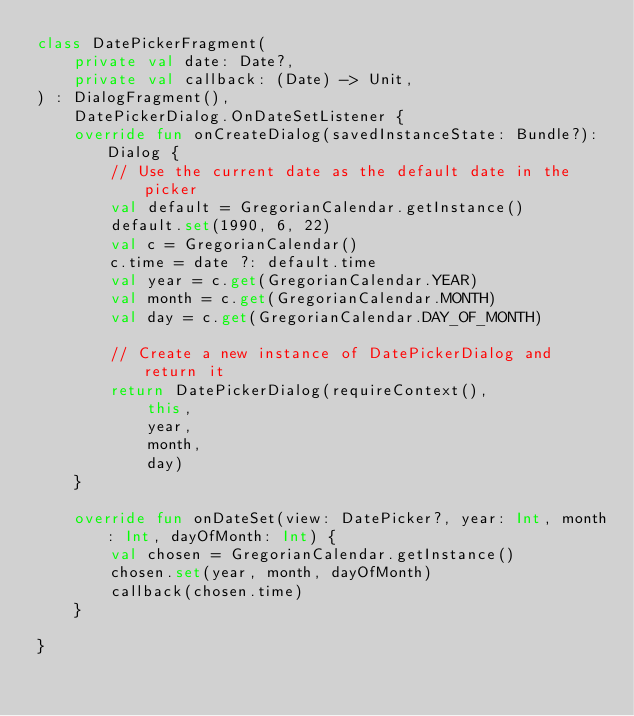<code> <loc_0><loc_0><loc_500><loc_500><_Kotlin_>class DatePickerFragment(
    private val date: Date?,
    private val callback: (Date) -> Unit,
) : DialogFragment(),
    DatePickerDialog.OnDateSetListener {
    override fun onCreateDialog(savedInstanceState: Bundle?): Dialog {
        // Use the current date as the default date in the picker
        val default = GregorianCalendar.getInstance()
        default.set(1990, 6, 22)
        val c = GregorianCalendar()
        c.time = date ?: default.time
        val year = c.get(GregorianCalendar.YEAR)
        val month = c.get(GregorianCalendar.MONTH)
        val day = c.get(GregorianCalendar.DAY_OF_MONTH)

        // Create a new instance of DatePickerDialog and return it
        return DatePickerDialog(requireContext(),
            this,
            year,
            month,
            day)
    }

    override fun onDateSet(view: DatePicker?, year: Int, month: Int, dayOfMonth: Int) {
        val chosen = GregorianCalendar.getInstance()
        chosen.set(year, month, dayOfMonth)
        callback(chosen.time)
    }

}</code> 